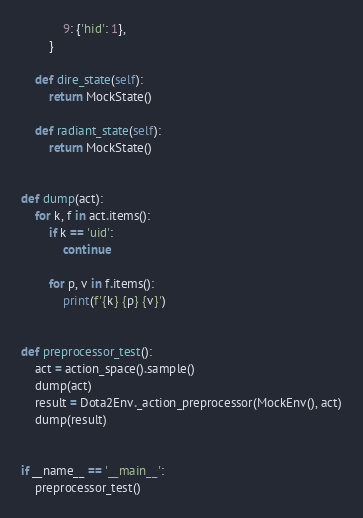<code> <loc_0><loc_0><loc_500><loc_500><_Python_>            9: {'hid': 1},
        }

    def dire_state(self):
        return MockState()

    def radiant_state(self):
        return MockState()


def dump(act):
    for k, f in act.items():
        if k == 'uid':
            continue

        for p, v in f.items():
            print(f'{k} {p} {v}')


def preprocessor_test():
    act = action_space().sample()
    dump(act)
    result = Dota2Env._action_preprocessor(MockEnv(), act)
    dump(result)


if __name__ == '__main__':
    preprocessor_test()
</code> 